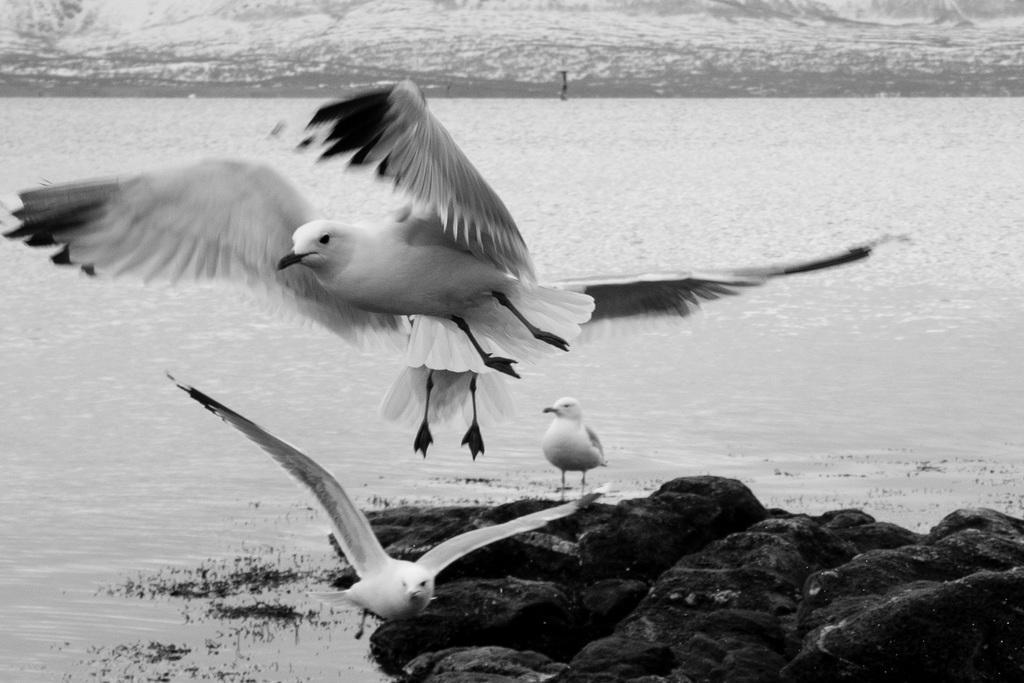In one or two sentences, can you explain what this image depicts? In this picture I can see there are few birds and it has few feathers and there is a lake in the backdrop and there is a rock. 